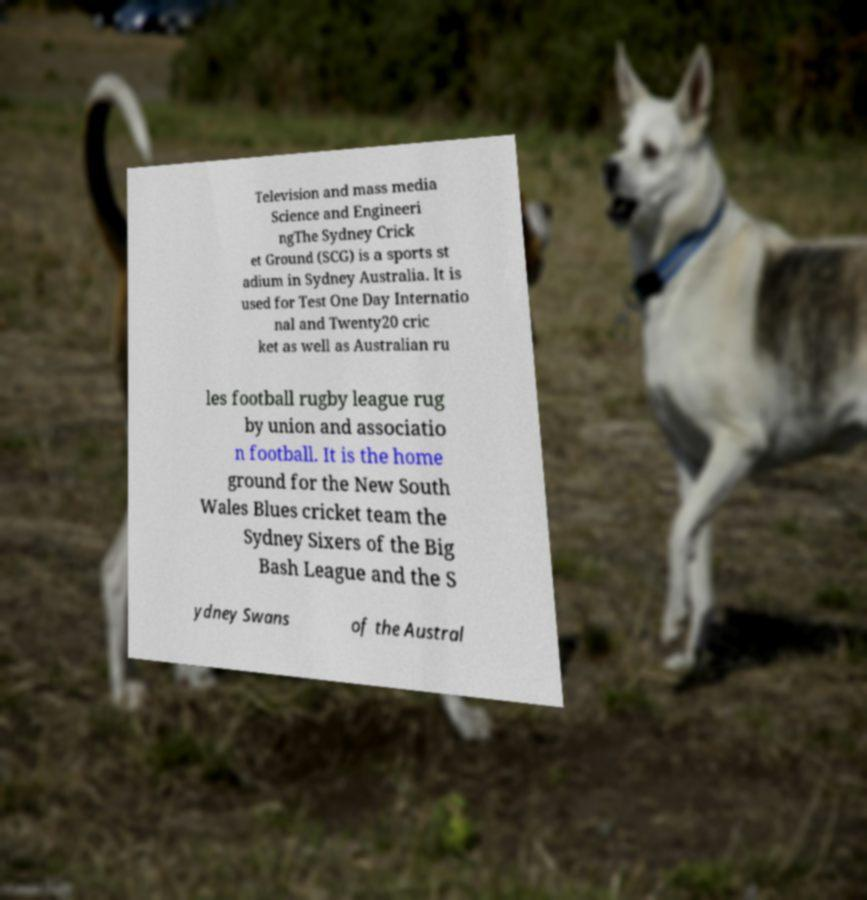Could you extract and type out the text from this image? Television and mass media Science and Engineeri ngThe Sydney Crick et Ground (SCG) is a sports st adium in Sydney Australia. It is used for Test One Day Internatio nal and Twenty20 cric ket as well as Australian ru les football rugby league rug by union and associatio n football. It is the home ground for the New South Wales Blues cricket team the Sydney Sixers of the Big Bash League and the S ydney Swans of the Austral 